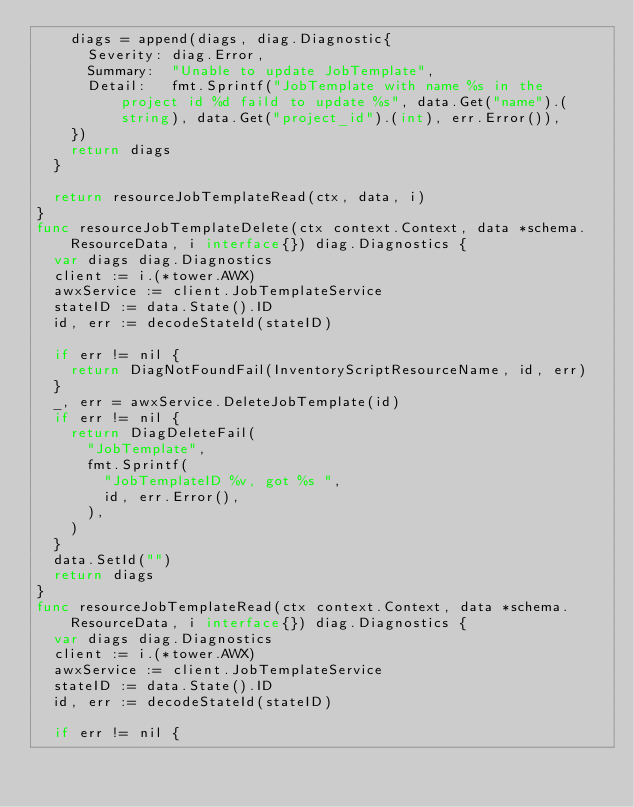Convert code to text. <code><loc_0><loc_0><loc_500><loc_500><_Go_>		diags = append(diags, diag.Diagnostic{
			Severity: diag.Error,
			Summary:  "Unable to update JobTemplate",
			Detail:   fmt.Sprintf("JobTemplate with name %s in the project id %d faild to update %s", data.Get("name").(string), data.Get("project_id").(int), err.Error()),
		})
		return diags
	}

	return resourceJobTemplateRead(ctx, data, i)
}
func resourceJobTemplateDelete(ctx context.Context, data *schema.ResourceData, i interface{}) diag.Diagnostics {
	var diags diag.Diagnostics
	client := i.(*tower.AWX)
	awxService := client.JobTemplateService
	stateID := data.State().ID
	id, err := decodeStateId(stateID)

	if err != nil {
		return DiagNotFoundFail(InventoryScriptResourceName, id, err)
	}
	_, err = awxService.DeleteJobTemplate(id)
	if err != nil {
		return DiagDeleteFail(
			"JobTemplate",
			fmt.Sprintf(
				"JobTemplateID %v, got %s ",
				id, err.Error(),
			),
		)
	}
	data.SetId("")
	return diags
}
func resourceJobTemplateRead(ctx context.Context, data *schema.ResourceData, i interface{}) diag.Diagnostics {
	var diags diag.Diagnostics
	client := i.(*tower.AWX)
	awxService := client.JobTemplateService
	stateID := data.State().ID
	id, err := decodeStateId(stateID)

	if err != nil {</code> 